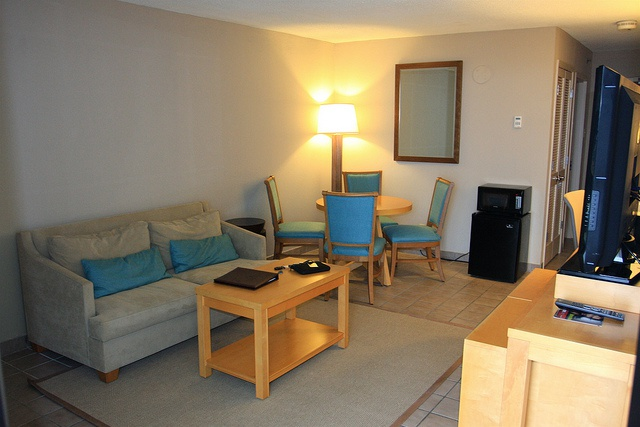Describe the objects in this image and their specific colors. I can see couch in gray, teal, and black tones, tv in gray, black, navy, and olive tones, chair in gray, teal, maroon, brown, and blue tones, refrigerator in gray, black, and darkgray tones, and chair in gray, brown, teal, and maroon tones in this image. 